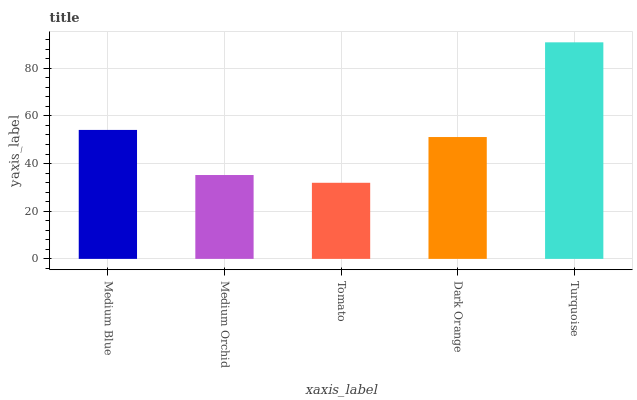Is Tomato the minimum?
Answer yes or no. Yes. Is Turquoise the maximum?
Answer yes or no. Yes. Is Medium Orchid the minimum?
Answer yes or no. No. Is Medium Orchid the maximum?
Answer yes or no. No. Is Medium Blue greater than Medium Orchid?
Answer yes or no. Yes. Is Medium Orchid less than Medium Blue?
Answer yes or no. Yes. Is Medium Orchid greater than Medium Blue?
Answer yes or no. No. Is Medium Blue less than Medium Orchid?
Answer yes or no. No. Is Dark Orange the high median?
Answer yes or no. Yes. Is Dark Orange the low median?
Answer yes or no. Yes. Is Medium Orchid the high median?
Answer yes or no. No. Is Turquoise the low median?
Answer yes or no. No. 